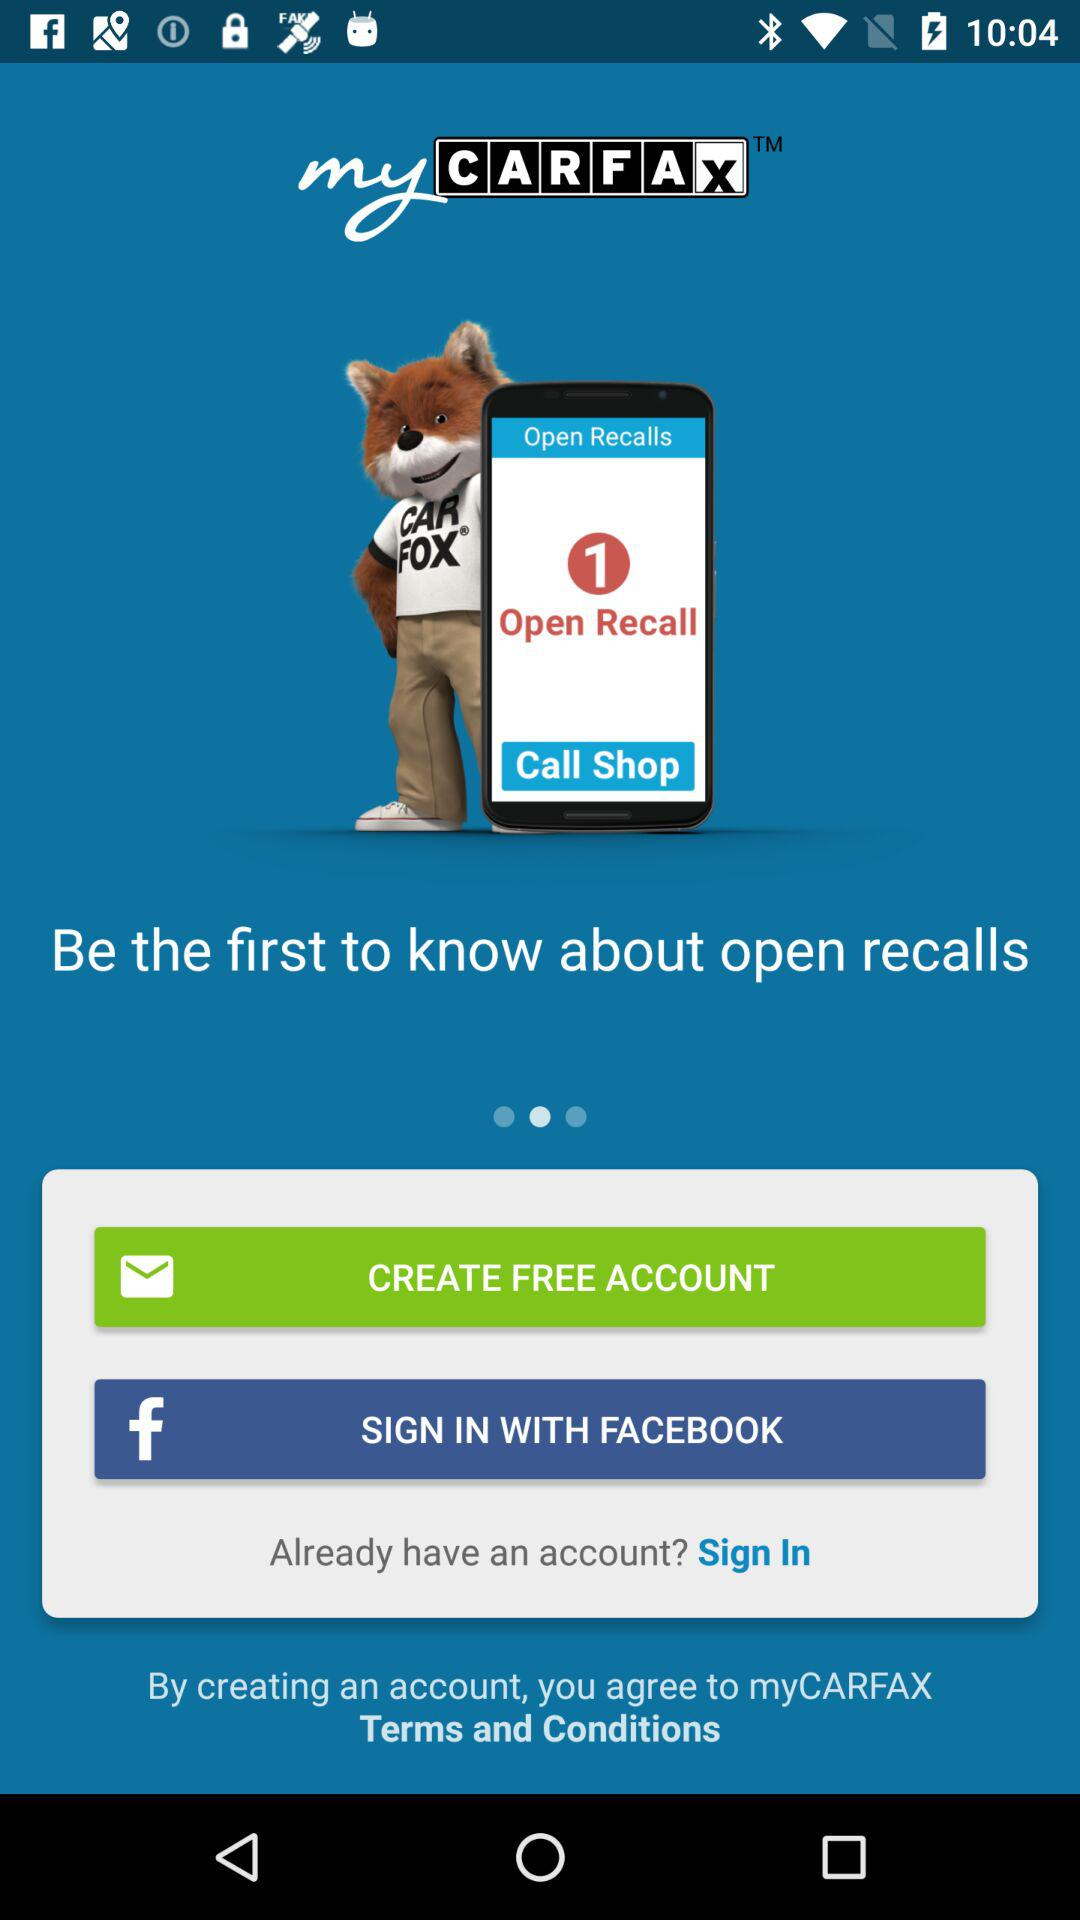Through what application can we sign in to the account? You can sign in to the account through "FACEBOOK". 